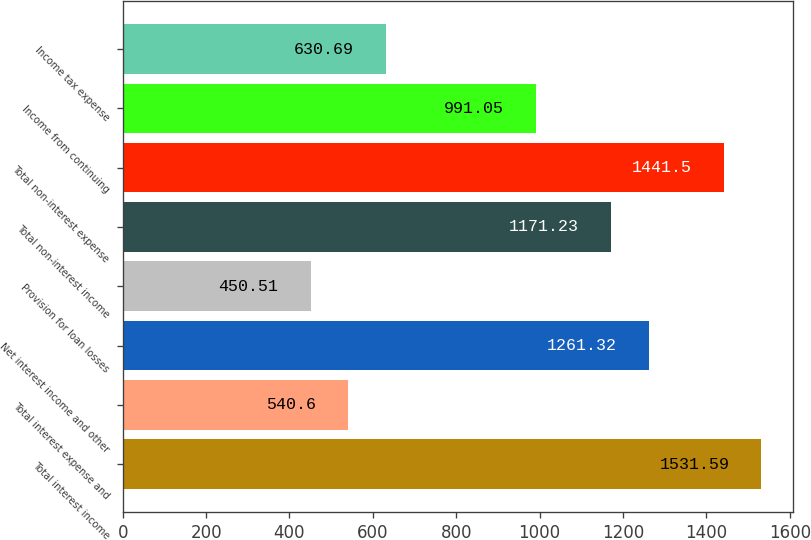Convert chart to OTSL. <chart><loc_0><loc_0><loc_500><loc_500><bar_chart><fcel>Total interest income<fcel>Total interest expense and<fcel>Net interest income and other<fcel>Provision for loan losses<fcel>Total non-interest income<fcel>Total non-interest expense<fcel>Income from continuing<fcel>Income tax expense<nl><fcel>1531.59<fcel>540.6<fcel>1261.32<fcel>450.51<fcel>1171.23<fcel>1441.5<fcel>991.05<fcel>630.69<nl></chart> 